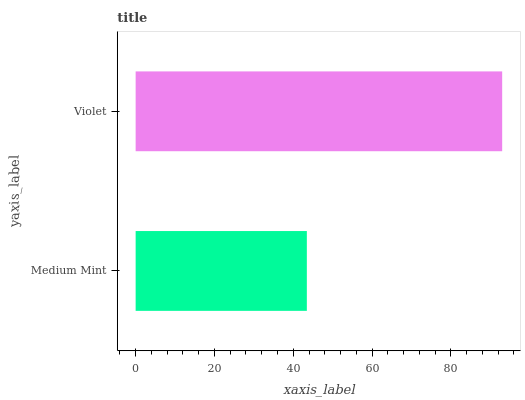Is Medium Mint the minimum?
Answer yes or no. Yes. Is Violet the maximum?
Answer yes or no. Yes. Is Violet the minimum?
Answer yes or no. No. Is Violet greater than Medium Mint?
Answer yes or no. Yes. Is Medium Mint less than Violet?
Answer yes or no. Yes. Is Medium Mint greater than Violet?
Answer yes or no. No. Is Violet less than Medium Mint?
Answer yes or no. No. Is Violet the high median?
Answer yes or no. Yes. Is Medium Mint the low median?
Answer yes or no. Yes. Is Medium Mint the high median?
Answer yes or no. No. Is Violet the low median?
Answer yes or no. No. 